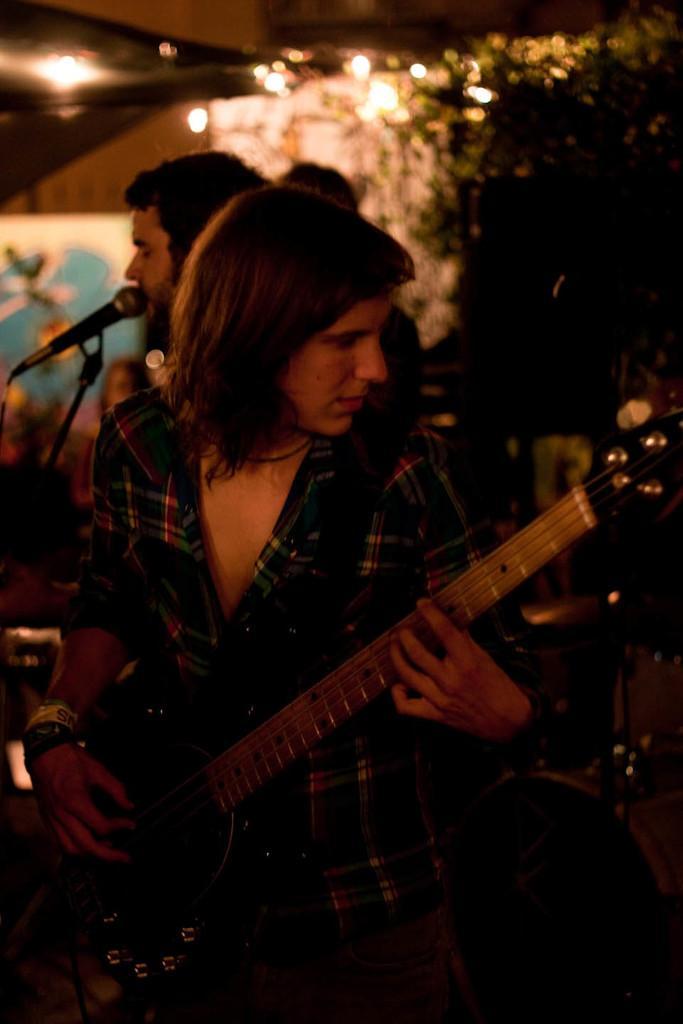Could you give a brief overview of what you see in this image? In this picture we can see three persons in front woman playing guitar and at back of her man singing on mic and in background we can see lights, tree. 